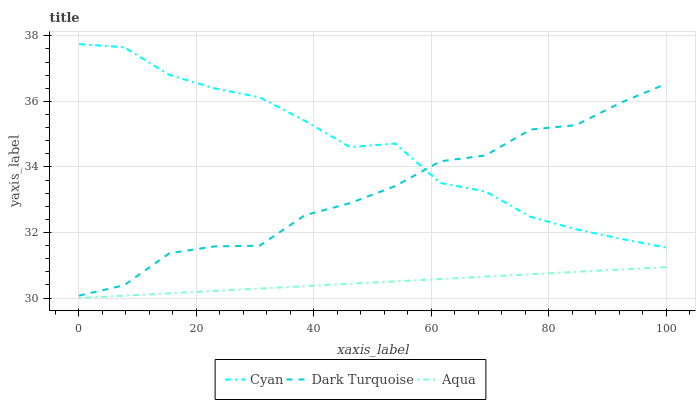Does Aqua have the minimum area under the curve?
Answer yes or no. Yes. Does Cyan have the maximum area under the curve?
Answer yes or no. Yes. Does Dark Turquoise have the minimum area under the curve?
Answer yes or no. No. Does Dark Turquoise have the maximum area under the curve?
Answer yes or no. No. Is Aqua the smoothest?
Answer yes or no. Yes. Is Cyan the roughest?
Answer yes or no. Yes. Is Dark Turquoise the smoothest?
Answer yes or no. No. Is Dark Turquoise the roughest?
Answer yes or no. No. Does Aqua have the lowest value?
Answer yes or no. Yes. Does Dark Turquoise have the lowest value?
Answer yes or no. No. Does Cyan have the highest value?
Answer yes or no. Yes. Does Dark Turquoise have the highest value?
Answer yes or no. No. Is Aqua less than Dark Turquoise?
Answer yes or no. Yes. Is Cyan greater than Aqua?
Answer yes or no. Yes. Does Cyan intersect Dark Turquoise?
Answer yes or no. Yes. Is Cyan less than Dark Turquoise?
Answer yes or no. No. Is Cyan greater than Dark Turquoise?
Answer yes or no. No. Does Aqua intersect Dark Turquoise?
Answer yes or no. No. 